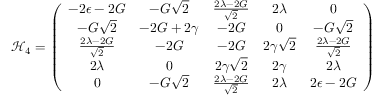<formula> <loc_0><loc_0><loc_500><loc_500>\mathcal { H } _ { 4 } = \left ( \begin{array} { c c c c c } { - 2 \epsilon - 2 G } & { - G \sqrt { 2 } } & { \frac { 2 \lambda - 2 G } { \sqrt { 2 } } } & { 2 \lambda } & { 0 } \\ { - G \sqrt { 2 } } & { - 2 G + 2 \gamma } & { - 2 G } & { 0 } & { - G \sqrt { 2 } } \\ { \frac { 2 \lambda - 2 G } { \sqrt { 2 } } } & { - 2 G } & { - 2 G } & { 2 \gamma \sqrt { 2 } } & { \frac { 2 \lambda - 2 G } { \sqrt { 2 } } } \\ { 2 \lambda } & { 0 } & { 2 \gamma \sqrt { 2 } } & { 2 \gamma } & { 2 \lambda } \\ { 0 } & { - G \sqrt { 2 } } & { \frac { 2 \lambda - 2 G } { \sqrt { 2 } } } & { 2 \lambda } & { 2 \epsilon - 2 G } \end{array} \right )</formula> 